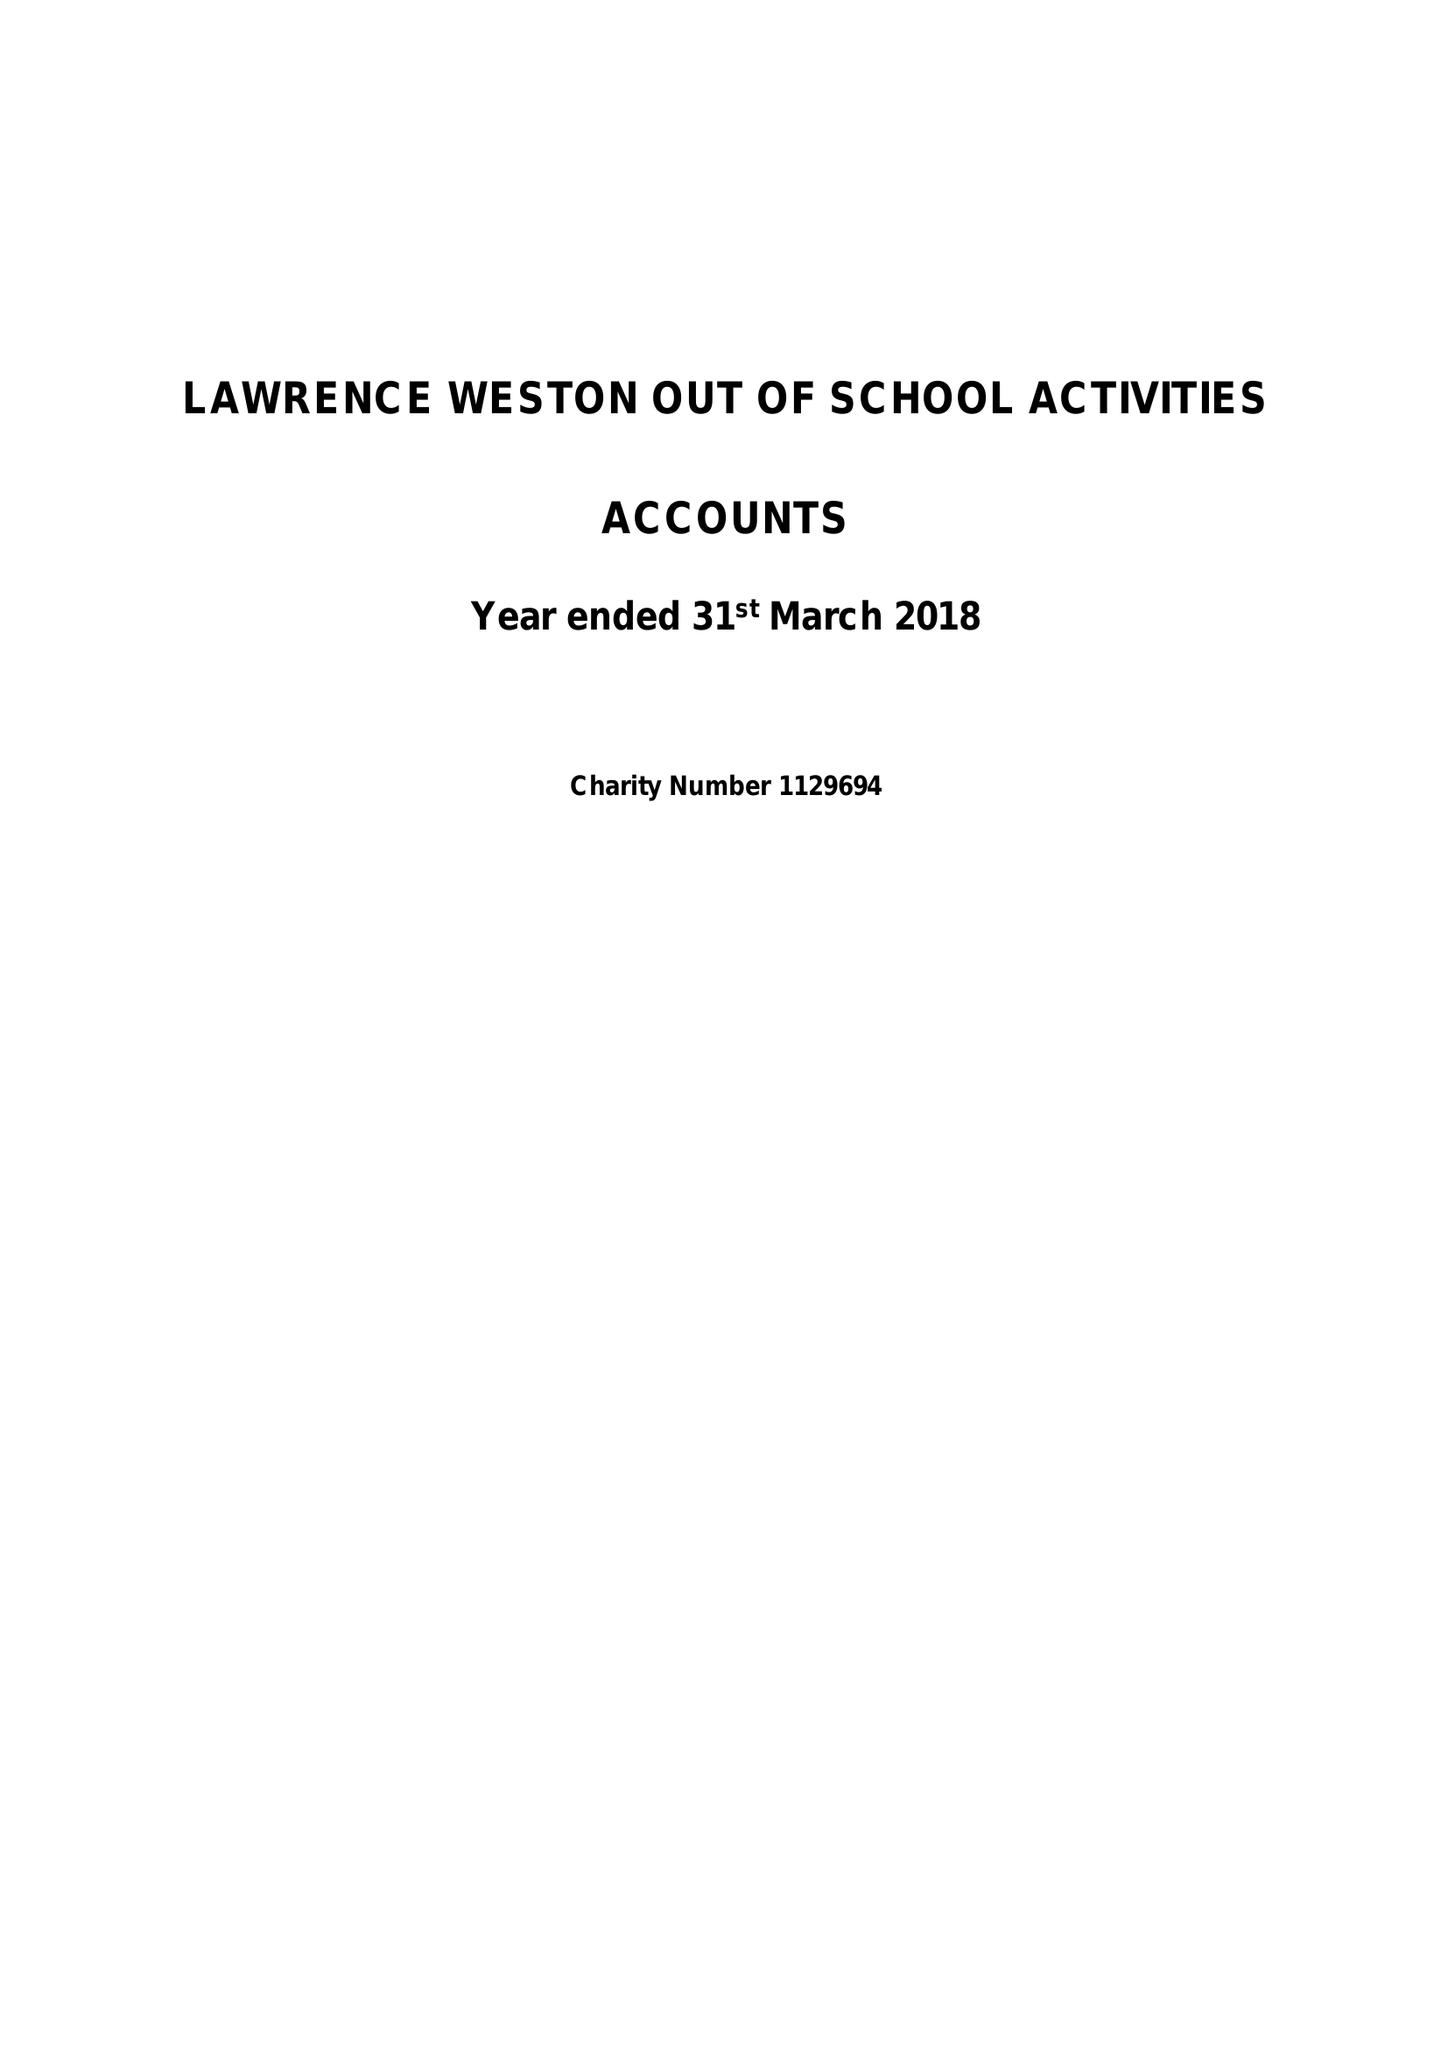What is the value for the report_date?
Answer the question using a single word or phrase. 2018-03-31 